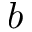Convert formula to latex. <formula><loc_0><loc_0><loc_500><loc_500>b</formula> 